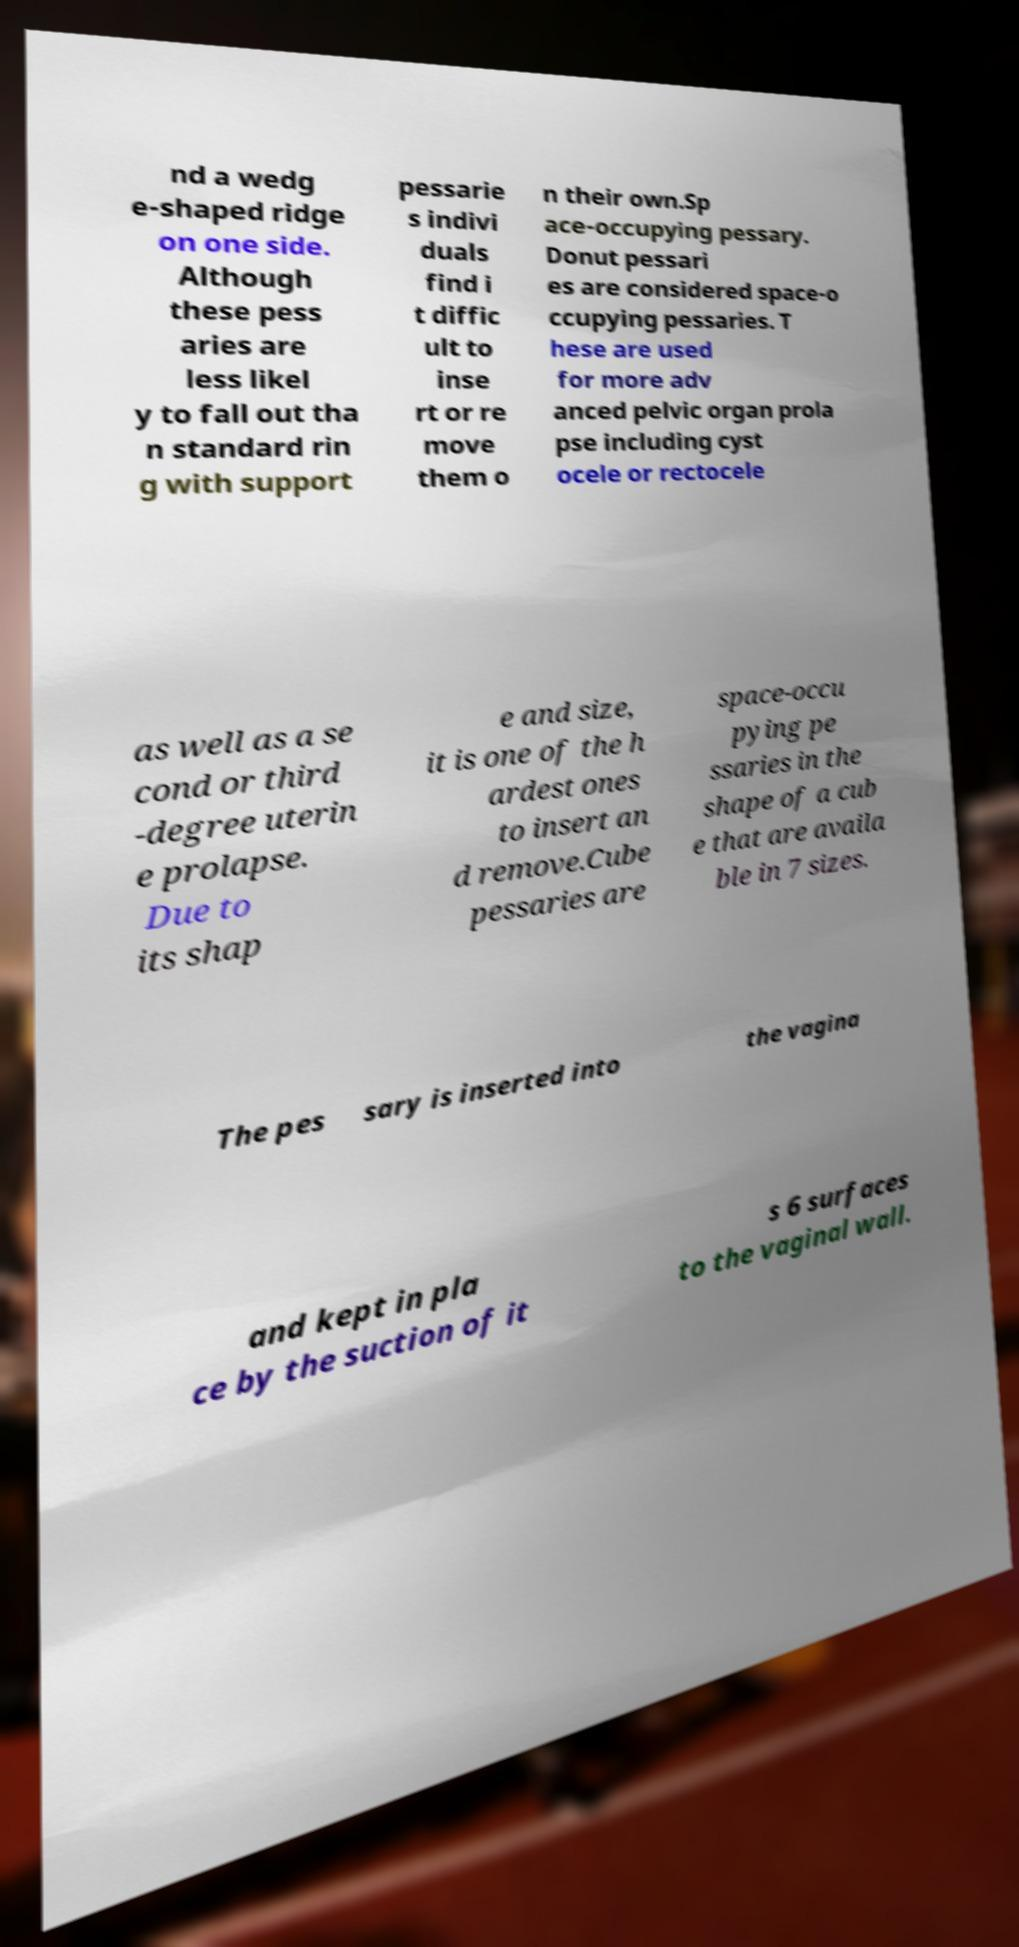Please read and relay the text visible in this image. What does it say? nd a wedg e-shaped ridge on one side. Although these pess aries are less likel y to fall out tha n standard rin g with support pessarie s indivi duals find i t diffic ult to inse rt or re move them o n their own.Sp ace-occupying pessary. Donut pessari es are considered space-o ccupying pessaries. T hese are used for more adv anced pelvic organ prola pse including cyst ocele or rectocele as well as a se cond or third -degree uterin e prolapse. Due to its shap e and size, it is one of the h ardest ones to insert an d remove.Cube pessaries are space-occu pying pe ssaries in the shape of a cub e that are availa ble in 7 sizes. The pes sary is inserted into the vagina and kept in pla ce by the suction of it s 6 surfaces to the vaginal wall. 